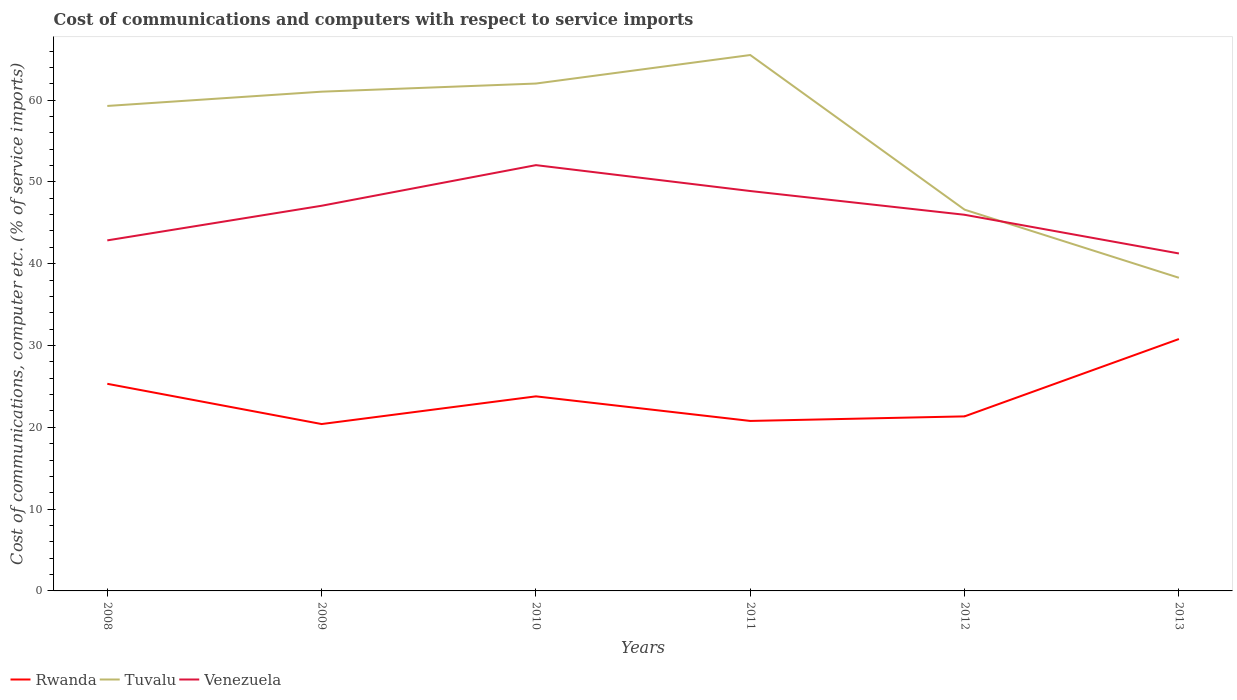How many different coloured lines are there?
Provide a short and direct response. 3. Does the line corresponding to Tuvalu intersect with the line corresponding to Rwanda?
Provide a succinct answer. No. Across all years, what is the maximum cost of communications and computers in Tuvalu?
Give a very brief answer. 38.28. In which year was the cost of communications and computers in Venezuela maximum?
Keep it short and to the point. 2013. What is the total cost of communications and computers in Venezuela in the graph?
Make the answer very short. 1.6. What is the difference between the highest and the second highest cost of communications and computers in Venezuela?
Keep it short and to the point. 10.8. What is the difference between the highest and the lowest cost of communications and computers in Venezuela?
Offer a very short reply. 3. Is the cost of communications and computers in Venezuela strictly greater than the cost of communications and computers in Rwanda over the years?
Give a very brief answer. No. How many lines are there?
Offer a terse response. 3. Where does the legend appear in the graph?
Your response must be concise. Bottom left. How many legend labels are there?
Give a very brief answer. 3. How are the legend labels stacked?
Make the answer very short. Horizontal. What is the title of the graph?
Your answer should be compact. Cost of communications and computers with respect to service imports. Does "Mauritania" appear as one of the legend labels in the graph?
Your response must be concise. No. What is the label or title of the X-axis?
Your answer should be very brief. Years. What is the label or title of the Y-axis?
Make the answer very short. Cost of communications, computer etc. (% of service imports). What is the Cost of communications, computer etc. (% of service imports) in Rwanda in 2008?
Give a very brief answer. 25.32. What is the Cost of communications, computer etc. (% of service imports) in Tuvalu in 2008?
Keep it short and to the point. 59.29. What is the Cost of communications, computer etc. (% of service imports) of Venezuela in 2008?
Provide a succinct answer. 42.85. What is the Cost of communications, computer etc. (% of service imports) of Rwanda in 2009?
Your answer should be very brief. 20.4. What is the Cost of communications, computer etc. (% of service imports) of Tuvalu in 2009?
Provide a succinct answer. 61.03. What is the Cost of communications, computer etc. (% of service imports) in Venezuela in 2009?
Your answer should be compact. 47.09. What is the Cost of communications, computer etc. (% of service imports) of Rwanda in 2010?
Offer a very short reply. 23.79. What is the Cost of communications, computer etc. (% of service imports) of Tuvalu in 2010?
Offer a very short reply. 62.03. What is the Cost of communications, computer etc. (% of service imports) in Venezuela in 2010?
Keep it short and to the point. 52.05. What is the Cost of communications, computer etc. (% of service imports) in Rwanda in 2011?
Provide a short and direct response. 20.78. What is the Cost of communications, computer etc. (% of service imports) in Tuvalu in 2011?
Your answer should be compact. 65.51. What is the Cost of communications, computer etc. (% of service imports) of Venezuela in 2011?
Keep it short and to the point. 48.89. What is the Cost of communications, computer etc. (% of service imports) in Rwanda in 2012?
Ensure brevity in your answer.  21.34. What is the Cost of communications, computer etc. (% of service imports) of Tuvalu in 2012?
Provide a short and direct response. 46.61. What is the Cost of communications, computer etc. (% of service imports) of Venezuela in 2012?
Your answer should be very brief. 45.98. What is the Cost of communications, computer etc. (% of service imports) of Rwanda in 2013?
Keep it short and to the point. 30.79. What is the Cost of communications, computer etc. (% of service imports) in Tuvalu in 2013?
Your answer should be very brief. 38.28. What is the Cost of communications, computer etc. (% of service imports) of Venezuela in 2013?
Offer a terse response. 41.25. Across all years, what is the maximum Cost of communications, computer etc. (% of service imports) of Rwanda?
Keep it short and to the point. 30.79. Across all years, what is the maximum Cost of communications, computer etc. (% of service imports) in Tuvalu?
Ensure brevity in your answer.  65.51. Across all years, what is the maximum Cost of communications, computer etc. (% of service imports) of Venezuela?
Your answer should be very brief. 52.05. Across all years, what is the minimum Cost of communications, computer etc. (% of service imports) in Rwanda?
Keep it short and to the point. 20.4. Across all years, what is the minimum Cost of communications, computer etc. (% of service imports) of Tuvalu?
Keep it short and to the point. 38.28. Across all years, what is the minimum Cost of communications, computer etc. (% of service imports) in Venezuela?
Your answer should be compact. 41.25. What is the total Cost of communications, computer etc. (% of service imports) in Rwanda in the graph?
Your response must be concise. 142.42. What is the total Cost of communications, computer etc. (% of service imports) in Tuvalu in the graph?
Make the answer very short. 332.75. What is the total Cost of communications, computer etc. (% of service imports) in Venezuela in the graph?
Provide a succinct answer. 278.11. What is the difference between the Cost of communications, computer etc. (% of service imports) of Rwanda in 2008 and that in 2009?
Offer a very short reply. 4.92. What is the difference between the Cost of communications, computer etc. (% of service imports) in Tuvalu in 2008 and that in 2009?
Provide a succinct answer. -1.75. What is the difference between the Cost of communications, computer etc. (% of service imports) in Venezuela in 2008 and that in 2009?
Give a very brief answer. -4.23. What is the difference between the Cost of communications, computer etc. (% of service imports) in Rwanda in 2008 and that in 2010?
Offer a terse response. 1.53. What is the difference between the Cost of communications, computer etc. (% of service imports) in Tuvalu in 2008 and that in 2010?
Your answer should be very brief. -2.74. What is the difference between the Cost of communications, computer etc. (% of service imports) in Venezuela in 2008 and that in 2010?
Make the answer very short. -9.2. What is the difference between the Cost of communications, computer etc. (% of service imports) of Rwanda in 2008 and that in 2011?
Your response must be concise. 4.54. What is the difference between the Cost of communications, computer etc. (% of service imports) in Tuvalu in 2008 and that in 2011?
Keep it short and to the point. -6.23. What is the difference between the Cost of communications, computer etc. (% of service imports) in Venezuela in 2008 and that in 2011?
Offer a terse response. -6.03. What is the difference between the Cost of communications, computer etc. (% of service imports) in Rwanda in 2008 and that in 2012?
Offer a terse response. 3.98. What is the difference between the Cost of communications, computer etc. (% of service imports) in Tuvalu in 2008 and that in 2012?
Your answer should be compact. 12.68. What is the difference between the Cost of communications, computer etc. (% of service imports) in Venezuela in 2008 and that in 2012?
Ensure brevity in your answer.  -3.13. What is the difference between the Cost of communications, computer etc. (% of service imports) in Rwanda in 2008 and that in 2013?
Ensure brevity in your answer.  -5.47. What is the difference between the Cost of communications, computer etc. (% of service imports) of Tuvalu in 2008 and that in 2013?
Your answer should be very brief. 21. What is the difference between the Cost of communications, computer etc. (% of service imports) of Venezuela in 2008 and that in 2013?
Offer a very short reply. 1.6. What is the difference between the Cost of communications, computer etc. (% of service imports) of Rwanda in 2009 and that in 2010?
Ensure brevity in your answer.  -3.39. What is the difference between the Cost of communications, computer etc. (% of service imports) in Tuvalu in 2009 and that in 2010?
Ensure brevity in your answer.  -0.99. What is the difference between the Cost of communications, computer etc. (% of service imports) of Venezuela in 2009 and that in 2010?
Make the answer very short. -4.96. What is the difference between the Cost of communications, computer etc. (% of service imports) in Rwanda in 2009 and that in 2011?
Offer a terse response. -0.38. What is the difference between the Cost of communications, computer etc. (% of service imports) of Tuvalu in 2009 and that in 2011?
Make the answer very short. -4.48. What is the difference between the Cost of communications, computer etc. (% of service imports) in Venezuela in 2009 and that in 2011?
Give a very brief answer. -1.8. What is the difference between the Cost of communications, computer etc. (% of service imports) of Rwanda in 2009 and that in 2012?
Give a very brief answer. -0.94. What is the difference between the Cost of communications, computer etc. (% of service imports) in Tuvalu in 2009 and that in 2012?
Provide a succinct answer. 14.43. What is the difference between the Cost of communications, computer etc. (% of service imports) of Venezuela in 2009 and that in 2012?
Provide a succinct answer. 1.1. What is the difference between the Cost of communications, computer etc. (% of service imports) in Rwanda in 2009 and that in 2013?
Give a very brief answer. -10.39. What is the difference between the Cost of communications, computer etc. (% of service imports) of Tuvalu in 2009 and that in 2013?
Ensure brevity in your answer.  22.75. What is the difference between the Cost of communications, computer etc. (% of service imports) in Venezuela in 2009 and that in 2013?
Your response must be concise. 5.83. What is the difference between the Cost of communications, computer etc. (% of service imports) of Rwanda in 2010 and that in 2011?
Make the answer very short. 3.01. What is the difference between the Cost of communications, computer etc. (% of service imports) in Tuvalu in 2010 and that in 2011?
Offer a terse response. -3.49. What is the difference between the Cost of communications, computer etc. (% of service imports) in Venezuela in 2010 and that in 2011?
Your response must be concise. 3.16. What is the difference between the Cost of communications, computer etc. (% of service imports) of Rwanda in 2010 and that in 2012?
Offer a very short reply. 2.45. What is the difference between the Cost of communications, computer etc. (% of service imports) of Tuvalu in 2010 and that in 2012?
Your response must be concise. 15.42. What is the difference between the Cost of communications, computer etc. (% of service imports) in Venezuela in 2010 and that in 2012?
Offer a terse response. 6.07. What is the difference between the Cost of communications, computer etc. (% of service imports) in Rwanda in 2010 and that in 2013?
Offer a very short reply. -7.01. What is the difference between the Cost of communications, computer etc. (% of service imports) of Tuvalu in 2010 and that in 2013?
Your answer should be compact. 23.74. What is the difference between the Cost of communications, computer etc. (% of service imports) in Venezuela in 2010 and that in 2013?
Provide a short and direct response. 10.8. What is the difference between the Cost of communications, computer etc. (% of service imports) in Rwanda in 2011 and that in 2012?
Keep it short and to the point. -0.56. What is the difference between the Cost of communications, computer etc. (% of service imports) of Tuvalu in 2011 and that in 2012?
Your answer should be compact. 18.91. What is the difference between the Cost of communications, computer etc. (% of service imports) of Venezuela in 2011 and that in 2012?
Provide a succinct answer. 2.9. What is the difference between the Cost of communications, computer etc. (% of service imports) in Rwanda in 2011 and that in 2013?
Offer a very short reply. -10.01. What is the difference between the Cost of communications, computer etc. (% of service imports) in Tuvalu in 2011 and that in 2013?
Provide a succinct answer. 27.23. What is the difference between the Cost of communications, computer etc. (% of service imports) of Venezuela in 2011 and that in 2013?
Provide a succinct answer. 7.63. What is the difference between the Cost of communications, computer etc. (% of service imports) in Rwanda in 2012 and that in 2013?
Provide a succinct answer. -9.45. What is the difference between the Cost of communications, computer etc. (% of service imports) of Tuvalu in 2012 and that in 2013?
Provide a short and direct response. 8.32. What is the difference between the Cost of communications, computer etc. (% of service imports) in Venezuela in 2012 and that in 2013?
Give a very brief answer. 4.73. What is the difference between the Cost of communications, computer etc. (% of service imports) in Rwanda in 2008 and the Cost of communications, computer etc. (% of service imports) in Tuvalu in 2009?
Keep it short and to the point. -35.71. What is the difference between the Cost of communications, computer etc. (% of service imports) of Rwanda in 2008 and the Cost of communications, computer etc. (% of service imports) of Venezuela in 2009?
Your response must be concise. -21.77. What is the difference between the Cost of communications, computer etc. (% of service imports) of Tuvalu in 2008 and the Cost of communications, computer etc. (% of service imports) of Venezuela in 2009?
Ensure brevity in your answer.  12.2. What is the difference between the Cost of communications, computer etc. (% of service imports) in Rwanda in 2008 and the Cost of communications, computer etc. (% of service imports) in Tuvalu in 2010?
Your response must be concise. -36.71. What is the difference between the Cost of communications, computer etc. (% of service imports) in Rwanda in 2008 and the Cost of communications, computer etc. (% of service imports) in Venezuela in 2010?
Offer a terse response. -26.73. What is the difference between the Cost of communications, computer etc. (% of service imports) in Tuvalu in 2008 and the Cost of communications, computer etc. (% of service imports) in Venezuela in 2010?
Your answer should be compact. 7.24. What is the difference between the Cost of communications, computer etc. (% of service imports) in Rwanda in 2008 and the Cost of communications, computer etc. (% of service imports) in Tuvalu in 2011?
Ensure brevity in your answer.  -40.19. What is the difference between the Cost of communications, computer etc. (% of service imports) in Rwanda in 2008 and the Cost of communications, computer etc. (% of service imports) in Venezuela in 2011?
Keep it short and to the point. -23.57. What is the difference between the Cost of communications, computer etc. (% of service imports) in Rwanda in 2008 and the Cost of communications, computer etc. (% of service imports) in Tuvalu in 2012?
Offer a terse response. -21.29. What is the difference between the Cost of communications, computer etc. (% of service imports) of Rwanda in 2008 and the Cost of communications, computer etc. (% of service imports) of Venezuela in 2012?
Give a very brief answer. -20.66. What is the difference between the Cost of communications, computer etc. (% of service imports) in Tuvalu in 2008 and the Cost of communications, computer etc. (% of service imports) in Venezuela in 2012?
Provide a short and direct response. 13.3. What is the difference between the Cost of communications, computer etc. (% of service imports) of Rwanda in 2008 and the Cost of communications, computer etc. (% of service imports) of Tuvalu in 2013?
Provide a succinct answer. -12.96. What is the difference between the Cost of communications, computer etc. (% of service imports) in Rwanda in 2008 and the Cost of communications, computer etc. (% of service imports) in Venezuela in 2013?
Keep it short and to the point. -15.93. What is the difference between the Cost of communications, computer etc. (% of service imports) in Tuvalu in 2008 and the Cost of communications, computer etc. (% of service imports) in Venezuela in 2013?
Give a very brief answer. 18.03. What is the difference between the Cost of communications, computer etc. (% of service imports) in Rwanda in 2009 and the Cost of communications, computer etc. (% of service imports) in Tuvalu in 2010?
Provide a succinct answer. -41.63. What is the difference between the Cost of communications, computer etc. (% of service imports) of Rwanda in 2009 and the Cost of communications, computer etc. (% of service imports) of Venezuela in 2010?
Your response must be concise. -31.65. What is the difference between the Cost of communications, computer etc. (% of service imports) of Tuvalu in 2009 and the Cost of communications, computer etc. (% of service imports) of Venezuela in 2010?
Provide a short and direct response. 8.98. What is the difference between the Cost of communications, computer etc. (% of service imports) in Rwanda in 2009 and the Cost of communications, computer etc. (% of service imports) in Tuvalu in 2011?
Offer a terse response. -45.11. What is the difference between the Cost of communications, computer etc. (% of service imports) of Rwanda in 2009 and the Cost of communications, computer etc. (% of service imports) of Venezuela in 2011?
Provide a succinct answer. -28.49. What is the difference between the Cost of communications, computer etc. (% of service imports) in Tuvalu in 2009 and the Cost of communications, computer etc. (% of service imports) in Venezuela in 2011?
Provide a succinct answer. 12.14. What is the difference between the Cost of communications, computer etc. (% of service imports) of Rwanda in 2009 and the Cost of communications, computer etc. (% of service imports) of Tuvalu in 2012?
Your answer should be compact. -26.21. What is the difference between the Cost of communications, computer etc. (% of service imports) of Rwanda in 2009 and the Cost of communications, computer etc. (% of service imports) of Venezuela in 2012?
Provide a succinct answer. -25.58. What is the difference between the Cost of communications, computer etc. (% of service imports) in Tuvalu in 2009 and the Cost of communications, computer etc. (% of service imports) in Venezuela in 2012?
Keep it short and to the point. 15.05. What is the difference between the Cost of communications, computer etc. (% of service imports) in Rwanda in 2009 and the Cost of communications, computer etc. (% of service imports) in Tuvalu in 2013?
Offer a very short reply. -17.88. What is the difference between the Cost of communications, computer etc. (% of service imports) in Rwanda in 2009 and the Cost of communications, computer etc. (% of service imports) in Venezuela in 2013?
Give a very brief answer. -20.85. What is the difference between the Cost of communications, computer etc. (% of service imports) in Tuvalu in 2009 and the Cost of communications, computer etc. (% of service imports) in Venezuela in 2013?
Provide a succinct answer. 19.78. What is the difference between the Cost of communications, computer etc. (% of service imports) in Rwanda in 2010 and the Cost of communications, computer etc. (% of service imports) in Tuvalu in 2011?
Your answer should be compact. -41.73. What is the difference between the Cost of communications, computer etc. (% of service imports) of Rwanda in 2010 and the Cost of communications, computer etc. (% of service imports) of Venezuela in 2011?
Your answer should be very brief. -25.1. What is the difference between the Cost of communications, computer etc. (% of service imports) in Tuvalu in 2010 and the Cost of communications, computer etc. (% of service imports) in Venezuela in 2011?
Your answer should be compact. 13.14. What is the difference between the Cost of communications, computer etc. (% of service imports) of Rwanda in 2010 and the Cost of communications, computer etc. (% of service imports) of Tuvalu in 2012?
Provide a succinct answer. -22.82. What is the difference between the Cost of communications, computer etc. (% of service imports) in Rwanda in 2010 and the Cost of communications, computer etc. (% of service imports) in Venezuela in 2012?
Offer a terse response. -22.2. What is the difference between the Cost of communications, computer etc. (% of service imports) of Tuvalu in 2010 and the Cost of communications, computer etc. (% of service imports) of Venezuela in 2012?
Your answer should be very brief. 16.04. What is the difference between the Cost of communications, computer etc. (% of service imports) of Rwanda in 2010 and the Cost of communications, computer etc. (% of service imports) of Tuvalu in 2013?
Give a very brief answer. -14.5. What is the difference between the Cost of communications, computer etc. (% of service imports) in Rwanda in 2010 and the Cost of communications, computer etc. (% of service imports) in Venezuela in 2013?
Provide a succinct answer. -17.47. What is the difference between the Cost of communications, computer etc. (% of service imports) of Tuvalu in 2010 and the Cost of communications, computer etc. (% of service imports) of Venezuela in 2013?
Offer a very short reply. 20.77. What is the difference between the Cost of communications, computer etc. (% of service imports) in Rwanda in 2011 and the Cost of communications, computer etc. (% of service imports) in Tuvalu in 2012?
Offer a terse response. -25.83. What is the difference between the Cost of communications, computer etc. (% of service imports) in Rwanda in 2011 and the Cost of communications, computer etc. (% of service imports) in Venezuela in 2012?
Make the answer very short. -25.2. What is the difference between the Cost of communications, computer etc. (% of service imports) in Tuvalu in 2011 and the Cost of communications, computer etc. (% of service imports) in Venezuela in 2012?
Your answer should be very brief. 19.53. What is the difference between the Cost of communications, computer etc. (% of service imports) in Rwanda in 2011 and the Cost of communications, computer etc. (% of service imports) in Tuvalu in 2013?
Provide a short and direct response. -17.5. What is the difference between the Cost of communications, computer etc. (% of service imports) of Rwanda in 2011 and the Cost of communications, computer etc. (% of service imports) of Venezuela in 2013?
Offer a very short reply. -20.47. What is the difference between the Cost of communications, computer etc. (% of service imports) of Tuvalu in 2011 and the Cost of communications, computer etc. (% of service imports) of Venezuela in 2013?
Keep it short and to the point. 24.26. What is the difference between the Cost of communications, computer etc. (% of service imports) in Rwanda in 2012 and the Cost of communications, computer etc. (% of service imports) in Tuvalu in 2013?
Your response must be concise. -16.94. What is the difference between the Cost of communications, computer etc. (% of service imports) of Rwanda in 2012 and the Cost of communications, computer etc. (% of service imports) of Venezuela in 2013?
Offer a terse response. -19.91. What is the difference between the Cost of communications, computer etc. (% of service imports) in Tuvalu in 2012 and the Cost of communications, computer etc. (% of service imports) in Venezuela in 2013?
Your answer should be very brief. 5.35. What is the average Cost of communications, computer etc. (% of service imports) of Rwanda per year?
Keep it short and to the point. 23.74. What is the average Cost of communications, computer etc. (% of service imports) in Tuvalu per year?
Your response must be concise. 55.46. What is the average Cost of communications, computer etc. (% of service imports) of Venezuela per year?
Ensure brevity in your answer.  46.35. In the year 2008, what is the difference between the Cost of communications, computer etc. (% of service imports) in Rwanda and Cost of communications, computer etc. (% of service imports) in Tuvalu?
Your response must be concise. -33.97. In the year 2008, what is the difference between the Cost of communications, computer etc. (% of service imports) in Rwanda and Cost of communications, computer etc. (% of service imports) in Venezuela?
Give a very brief answer. -17.53. In the year 2008, what is the difference between the Cost of communications, computer etc. (% of service imports) in Tuvalu and Cost of communications, computer etc. (% of service imports) in Venezuela?
Provide a short and direct response. 16.43. In the year 2009, what is the difference between the Cost of communications, computer etc. (% of service imports) of Rwanda and Cost of communications, computer etc. (% of service imports) of Tuvalu?
Make the answer very short. -40.63. In the year 2009, what is the difference between the Cost of communications, computer etc. (% of service imports) of Rwanda and Cost of communications, computer etc. (% of service imports) of Venezuela?
Provide a succinct answer. -26.69. In the year 2009, what is the difference between the Cost of communications, computer etc. (% of service imports) of Tuvalu and Cost of communications, computer etc. (% of service imports) of Venezuela?
Ensure brevity in your answer.  13.95. In the year 2010, what is the difference between the Cost of communications, computer etc. (% of service imports) in Rwanda and Cost of communications, computer etc. (% of service imports) in Tuvalu?
Keep it short and to the point. -38.24. In the year 2010, what is the difference between the Cost of communications, computer etc. (% of service imports) in Rwanda and Cost of communications, computer etc. (% of service imports) in Venezuela?
Your answer should be compact. -28.27. In the year 2010, what is the difference between the Cost of communications, computer etc. (% of service imports) of Tuvalu and Cost of communications, computer etc. (% of service imports) of Venezuela?
Provide a succinct answer. 9.97. In the year 2011, what is the difference between the Cost of communications, computer etc. (% of service imports) of Rwanda and Cost of communications, computer etc. (% of service imports) of Tuvalu?
Your response must be concise. -44.73. In the year 2011, what is the difference between the Cost of communications, computer etc. (% of service imports) of Rwanda and Cost of communications, computer etc. (% of service imports) of Venezuela?
Ensure brevity in your answer.  -28.11. In the year 2011, what is the difference between the Cost of communications, computer etc. (% of service imports) of Tuvalu and Cost of communications, computer etc. (% of service imports) of Venezuela?
Give a very brief answer. 16.63. In the year 2012, what is the difference between the Cost of communications, computer etc. (% of service imports) of Rwanda and Cost of communications, computer etc. (% of service imports) of Tuvalu?
Your answer should be very brief. -25.27. In the year 2012, what is the difference between the Cost of communications, computer etc. (% of service imports) in Rwanda and Cost of communications, computer etc. (% of service imports) in Venezuela?
Provide a short and direct response. -24.64. In the year 2012, what is the difference between the Cost of communications, computer etc. (% of service imports) of Tuvalu and Cost of communications, computer etc. (% of service imports) of Venezuela?
Give a very brief answer. 0.62. In the year 2013, what is the difference between the Cost of communications, computer etc. (% of service imports) in Rwanda and Cost of communications, computer etc. (% of service imports) in Tuvalu?
Provide a short and direct response. -7.49. In the year 2013, what is the difference between the Cost of communications, computer etc. (% of service imports) in Rwanda and Cost of communications, computer etc. (% of service imports) in Venezuela?
Provide a short and direct response. -10.46. In the year 2013, what is the difference between the Cost of communications, computer etc. (% of service imports) of Tuvalu and Cost of communications, computer etc. (% of service imports) of Venezuela?
Your answer should be compact. -2.97. What is the ratio of the Cost of communications, computer etc. (% of service imports) of Rwanda in 2008 to that in 2009?
Keep it short and to the point. 1.24. What is the ratio of the Cost of communications, computer etc. (% of service imports) of Tuvalu in 2008 to that in 2009?
Your answer should be compact. 0.97. What is the ratio of the Cost of communications, computer etc. (% of service imports) of Venezuela in 2008 to that in 2009?
Make the answer very short. 0.91. What is the ratio of the Cost of communications, computer etc. (% of service imports) in Rwanda in 2008 to that in 2010?
Ensure brevity in your answer.  1.06. What is the ratio of the Cost of communications, computer etc. (% of service imports) in Tuvalu in 2008 to that in 2010?
Keep it short and to the point. 0.96. What is the ratio of the Cost of communications, computer etc. (% of service imports) of Venezuela in 2008 to that in 2010?
Make the answer very short. 0.82. What is the ratio of the Cost of communications, computer etc. (% of service imports) of Rwanda in 2008 to that in 2011?
Offer a terse response. 1.22. What is the ratio of the Cost of communications, computer etc. (% of service imports) of Tuvalu in 2008 to that in 2011?
Give a very brief answer. 0.91. What is the ratio of the Cost of communications, computer etc. (% of service imports) of Venezuela in 2008 to that in 2011?
Give a very brief answer. 0.88. What is the ratio of the Cost of communications, computer etc. (% of service imports) of Rwanda in 2008 to that in 2012?
Keep it short and to the point. 1.19. What is the ratio of the Cost of communications, computer etc. (% of service imports) in Tuvalu in 2008 to that in 2012?
Make the answer very short. 1.27. What is the ratio of the Cost of communications, computer etc. (% of service imports) of Venezuela in 2008 to that in 2012?
Make the answer very short. 0.93. What is the ratio of the Cost of communications, computer etc. (% of service imports) of Rwanda in 2008 to that in 2013?
Your answer should be very brief. 0.82. What is the ratio of the Cost of communications, computer etc. (% of service imports) of Tuvalu in 2008 to that in 2013?
Give a very brief answer. 1.55. What is the ratio of the Cost of communications, computer etc. (% of service imports) in Venezuela in 2008 to that in 2013?
Offer a terse response. 1.04. What is the ratio of the Cost of communications, computer etc. (% of service imports) in Rwanda in 2009 to that in 2010?
Provide a short and direct response. 0.86. What is the ratio of the Cost of communications, computer etc. (% of service imports) in Venezuela in 2009 to that in 2010?
Offer a very short reply. 0.9. What is the ratio of the Cost of communications, computer etc. (% of service imports) of Rwanda in 2009 to that in 2011?
Offer a very short reply. 0.98. What is the ratio of the Cost of communications, computer etc. (% of service imports) of Tuvalu in 2009 to that in 2011?
Offer a very short reply. 0.93. What is the ratio of the Cost of communications, computer etc. (% of service imports) of Venezuela in 2009 to that in 2011?
Your response must be concise. 0.96. What is the ratio of the Cost of communications, computer etc. (% of service imports) in Rwanda in 2009 to that in 2012?
Ensure brevity in your answer.  0.96. What is the ratio of the Cost of communications, computer etc. (% of service imports) in Tuvalu in 2009 to that in 2012?
Give a very brief answer. 1.31. What is the ratio of the Cost of communications, computer etc. (% of service imports) in Rwanda in 2009 to that in 2013?
Your response must be concise. 0.66. What is the ratio of the Cost of communications, computer etc. (% of service imports) of Tuvalu in 2009 to that in 2013?
Keep it short and to the point. 1.59. What is the ratio of the Cost of communications, computer etc. (% of service imports) in Venezuela in 2009 to that in 2013?
Keep it short and to the point. 1.14. What is the ratio of the Cost of communications, computer etc. (% of service imports) in Rwanda in 2010 to that in 2011?
Ensure brevity in your answer.  1.14. What is the ratio of the Cost of communications, computer etc. (% of service imports) of Tuvalu in 2010 to that in 2011?
Your answer should be very brief. 0.95. What is the ratio of the Cost of communications, computer etc. (% of service imports) in Venezuela in 2010 to that in 2011?
Offer a terse response. 1.06. What is the ratio of the Cost of communications, computer etc. (% of service imports) in Rwanda in 2010 to that in 2012?
Offer a very short reply. 1.11. What is the ratio of the Cost of communications, computer etc. (% of service imports) of Tuvalu in 2010 to that in 2012?
Your answer should be very brief. 1.33. What is the ratio of the Cost of communications, computer etc. (% of service imports) of Venezuela in 2010 to that in 2012?
Make the answer very short. 1.13. What is the ratio of the Cost of communications, computer etc. (% of service imports) in Rwanda in 2010 to that in 2013?
Give a very brief answer. 0.77. What is the ratio of the Cost of communications, computer etc. (% of service imports) in Tuvalu in 2010 to that in 2013?
Your answer should be compact. 1.62. What is the ratio of the Cost of communications, computer etc. (% of service imports) of Venezuela in 2010 to that in 2013?
Your answer should be very brief. 1.26. What is the ratio of the Cost of communications, computer etc. (% of service imports) in Rwanda in 2011 to that in 2012?
Your answer should be compact. 0.97. What is the ratio of the Cost of communications, computer etc. (% of service imports) in Tuvalu in 2011 to that in 2012?
Offer a terse response. 1.41. What is the ratio of the Cost of communications, computer etc. (% of service imports) of Venezuela in 2011 to that in 2012?
Give a very brief answer. 1.06. What is the ratio of the Cost of communications, computer etc. (% of service imports) in Rwanda in 2011 to that in 2013?
Your answer should be compact. 0.67. What is the ratio of the Cost of communications, computer etc. (% of service imports) of Tuvalu in 2011 to that in 2013?
Provide a succinct answer. 1.71. What is the ratio of the Cost of communications, computer etc. (% of service imports) of Venezuela in 2011 to that in 2013?
Provide a succinct answer. 1.19. What is the ratio of the Cost of communications, computer etc. (% of service imports) in Rwanda in 2012 to that in 2013?
Keep it short and to the point. 0.69. What is the ratio of the Cost of communications, computer etc. (% of service imports) of Tuvalu in 2012 to that in 2013?
Keep it short and to the point. 1.22. What is the ratio of the Cost of communications, computer etc. (% of service imports) of Venezuela in 2012 to that in 2013?
Offer a very short reply. 1.11. What is the difference between the highest and the second highest Cost of communications, computer etc. (% of service imports) of Rwanda?
Offer a terse response. 5.47. What is the difference between the highest and the second highest Cost of communications, computer etc. (% of service imports) in Tuvalu?
Keep it short and to the point. 3.49. What is the difference between the highest and the second highest Cost of communications, computer etc. (% of service imports) in Venezuela?
Ensure brevity in your answer.  3.16. What is the difference between the highest and the lowest Cost of communications, computer etc. (% of service imports) of Rwanda?
Offer a very short reply. 10.39. What is the difference between the highest and the lowest Cost of communications, computer etc. (% of service imports) in Tuvalu?
Give a very brief answer. 27.23. What is the difference between the highest and the lowest Cost of communications, computer etc. (% of service imports) of Venezuela?
Provide a short and direct response. 10.8. 